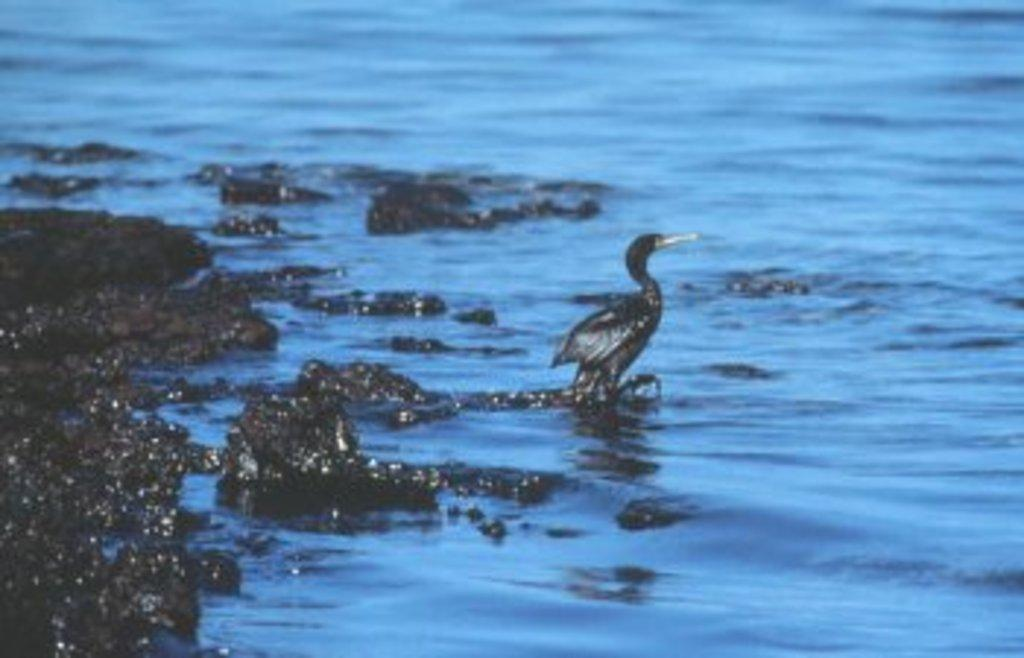What type of animal can be seen in the water in the image? There is a bird in the water in the image. What other objects can be seen in the image? There are stones visible in the image. How many zebras can be seen grazing on the territory in the image? There are no zebras or territory present in the image; it features a bird in the water and stones. What type of mice can be seen interacting with the bird in the image? There are no mice present in the image; it features a bird in the water and stones. 